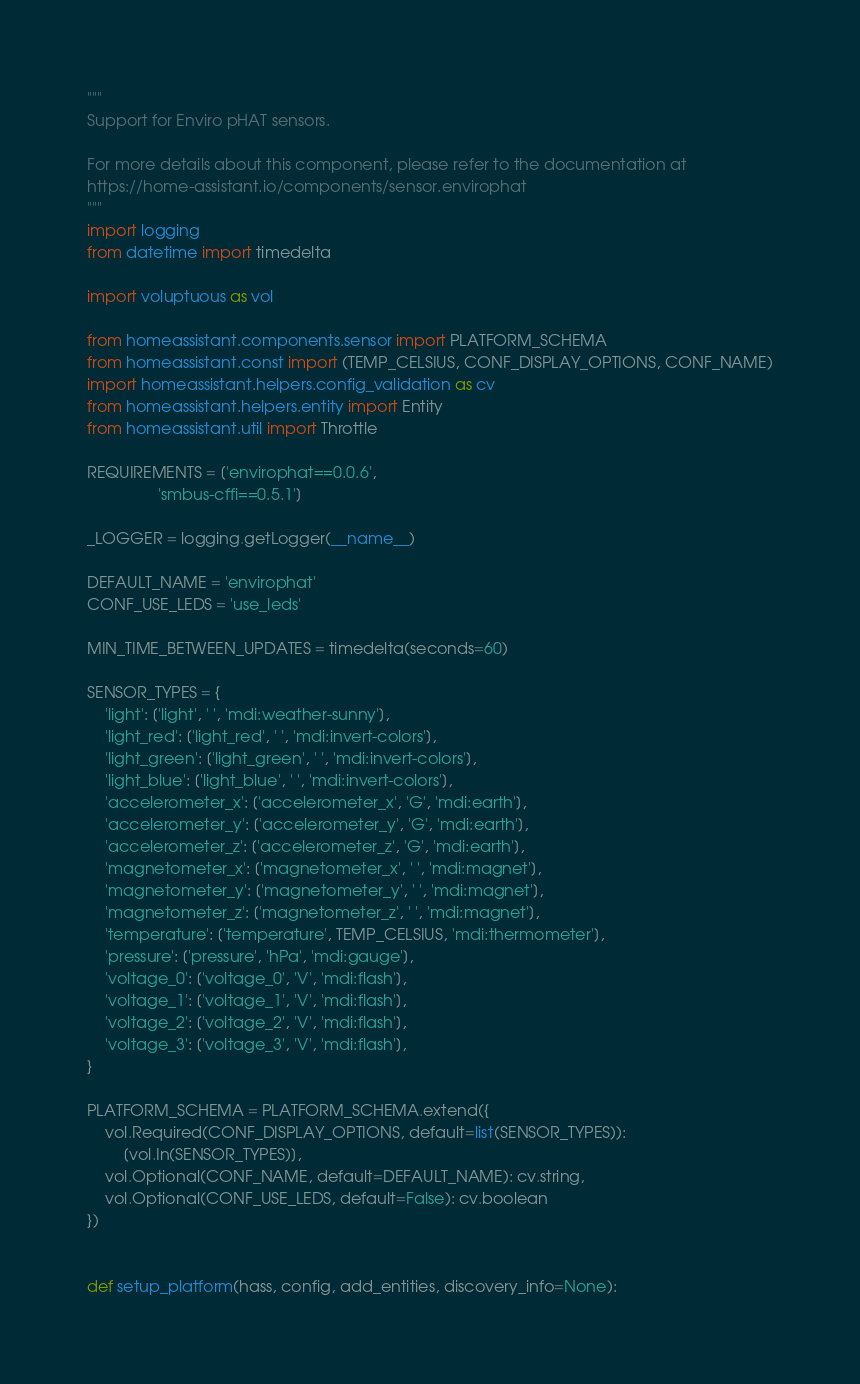<code> <loc_0><loc_0><loc_500><loc_500><_Python_>"""
Support for Enviro pHAT sensors.

For more details about this component, please refer to the documentation at
https://home-assistant.io/components/sensor.envirophat
"""
import logging
from datetime import timedelta

import voluptuous as vol

from homeassistant.components.sensor import PLATFORM_SCHEMA
from homeassistant.const import (TEMP_CELSIUS, CONF_DISPLAY_OPTIONS, CONF_NAME)
import homeassistant.helpers.config_validation as cv
from homeassistant.helpers.entity import Entity
from homeassistant.util import Throttle

REQUIREMENTS = ['envirophat==0.0.6',
                'smbus-cffi==0.5.1']

_LOGGER = logging.getLogger(__name__)

DEFAULT_NAME = 'envirophat'
CONF_USE_LEDS = 'use_leds'

MIN_TIME_BETWEEN_UPDATES = timedelta(seconds=60)

SENSOR_TYPES = {
    'light': ['light', ' ', 'mdi:weather-sunny'],
    'light_red': ['light_red', ' ', 'mdi:invert-colors'],
    'light_green': ['light_green', ' ', 'mdi:invert-colors'],
    'light_blue': ['light_blue', ' ', 'mdi:invert-colors'],
    'accelerometer_x': ['accelerometer_x', 'G', 'mdi:earth'],
    'accelerometer_y': ['accelerometer_y', 'G', 'mdi:earth'],
    'accelerometer_z': ['accelerometer_z', 'G', 'mdi:earth'],
    'magnetometer_x': ['magnetometer_x', ' ', 'mdi:magnet'],
    'magnetometer_y': ['magnetometer_y', ' ', 'mdi:magnet'],
    'magnetometer_z': ['magnetometer_z', ' ', 'mdi:magnet'],
    'temperature': ['temperature', TEMP_CELSIUS, 'mdi:thermometer'],
    'pressure': ['pressure', 'hPa', 'mdi:gauge'],
    'voltage_0': ['voltage_0', 'V', 'mdi:flash'],
    'voltage_1': ['voltage_1', 'V', 'mdi:flash'],
    'voltage_2': ['voltage_2', 'V', 'mdi:flash'],
    'voltage_3': ['voltage_3', 'V', 'mdi:flash'],
}

PLATFORM_SCHEMA = PLATFORM_SCHEMA.extend({
    vol.Required(CONF_DISPLAY_OPTIONS, default=list(SENSOR_TYPES)):
        [vol.In(SENSOR_TYPES)],
    vol.Optional(CONF_NAME, default=DEFAULT_NAME): cv.string,
    vol.Optional(CONF_USE_LEDS, default=False): cv.boolean
})


def setup_platform(hass, config, add_entities, discovery_info=None):</code> 